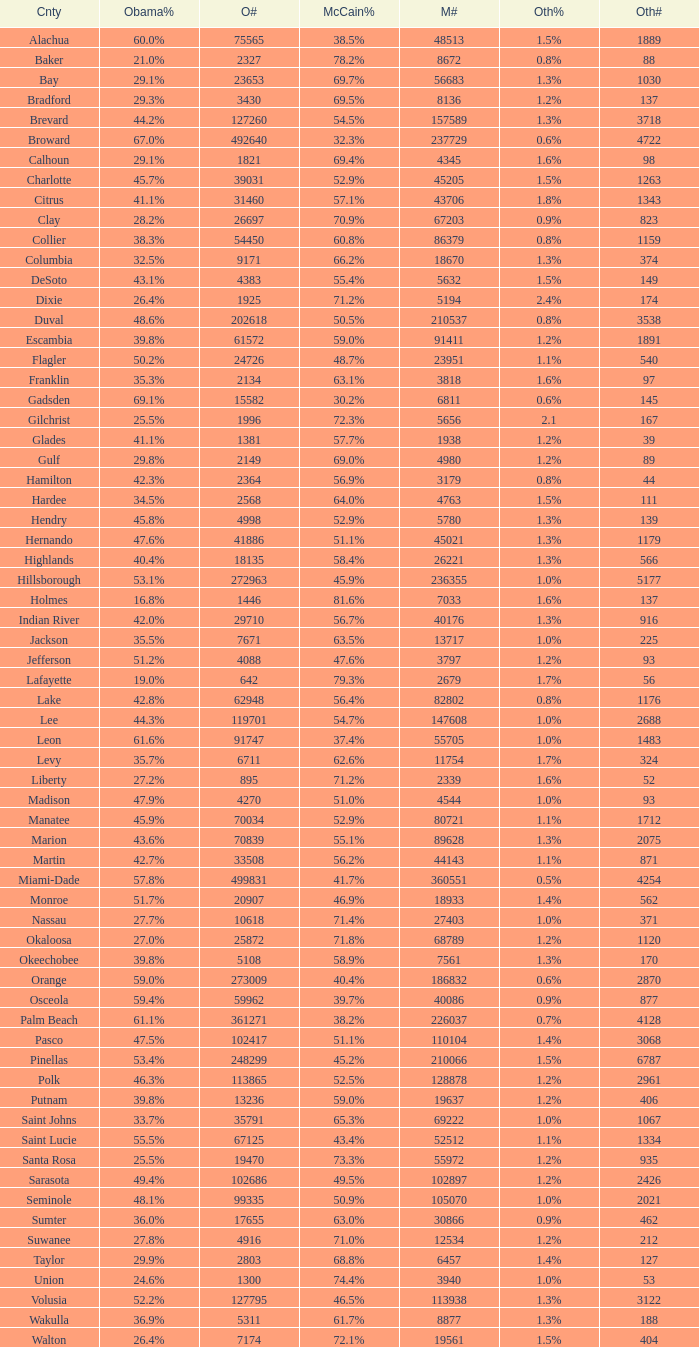Parse the full table. {'header': ['Cnty', 'Obama%', 'O#', 'McCain%', 'M#', 'Oth%', 'Oth#'], 'rows': [['Alachua', '60.0%', '75565', '38.5%', '48513', '1.5%', '1889'], ['Baker', '21.0%', '2327', '78.2%', '8672', '0.8%', '88'], ['Bay', '29.1%', '23653', '69.7%', '56683', '1.3%', '1030'], ['Bradford', '29.3%', '3430', '69.5%', '8136', '1.2%', '137'], ['Brevard', '44.2%', '127260', '54.5%', '157589', '1.3%', '3718'], ['Broward', '67.0%', '492640', '32.3%', '237729', '0.6%', '4722'], ['Calhoun', '29.1%', '1821', '69.4%', '4345', '1.6%', '98'], ['Charlotte', '45.7%', '39031', '52.9%', '45205', '1.5%', '1263'], ['Citrus', '41.1%', '31460', '57.1%', '43706', '1.8%', '1343'], ['Clay', '28.2%', '26697', '70.9%', '67203', '0.9%', '823'], ['Collier', '38.3%', '54450', '60.8%', '86379', '0.8%', '1159'], ['Columbia', '32.5%', '9171', '66.2%', '18670', '1.3%', '374'], ['DeSoto', '43.1%', '4383', '55.4%', '5632', '1.5%', '149'], ['Dixie', '26.4%', '1925', '71.2%', '5194', '2.4%', '174'], ['Duval', '48.6%', '202618', '50.5%', '210537', '0.8%', '3538'], ['Escambia', '39.8%', '61572', '59.0%', '91411', '1.2%', '1891'], ['Flagler', '50.2%', '24726', '48.7%', '23951', '1.1%', '540'], ['Franklin', '35.3%', '2134', '63.1%', '3818', '1.6%', '97'], ['Gadsden', '69.1%', '15582', '30.2%', '6811', '0.6%', '145'], ['Gilchrist', '25.5%', '1996', '72.3%', '5656', '2.1', '167'], ['Glades', '41.1%', '1381', '57.7%', '1938', '1.2%', '39'], ['Gulf', '29.8%', '2149', '69.0%', '4980', '1.2%', '89'], ['Hamilton', '42.3%', '2364', '56.9%', '3179', '0.8%', '44'], ['Hardee', '34.5%', '2568', '64.0%', '4763', '1.5%', '111'], ['Hendry', '45.8%', '4998', '52.9%', '5780', '1.3%', '139'], ['Hernando', '47.6%', '41886', '51.1%', '45021', '1.3%', '1179'], ['Highlands', '40.4%', '18135', '58.4%', '26221', '1.3%', '566'], ['Hillsborough', '53.1%', '272963', '45.9%', '236355', '1.0%', '5177'], ['Holmes', '16.8%', '1446', '81.6%', '7033', '1.6%', '137'], ['Indian River', '42.0%', '29710', '56.7%', '40176', '1.3%', '916'], ['Jackson', '35.5%', '7671', '63.5%', '13717', '1.0%', '225'], ['Jefferson', '51.2%', '4088', '47.6%', '3797', '1.2%', '93'], ['Lafayette', '19.0%', '642', '79.3%', '2679', '1.7%', '56'], ['Lake', '42.8%', '62948', '56.4%', '82802', '0.8%', '1176'], ['Lee', '44.3%', '119701', '54.7%', '147608', '1.0%', '2688'], ['Leon', '61.6%', '91747', '37.4%', '55705', '1.0%', '1483'], ['Levy', '35.7%', '6711', '62.6%', '11754', '1.7%', '324'], ['Liberty', '27.2%', '895', '71.2%', '2339', '1.6%', '52'], ['Madison', '47.9%', '4270', '51.0%', '4544', '1.0%', '93'], ['Manatee', '45.9%', '70034', '52.9%', '80721', '1.1%', '1712'], ['Marion', '43.6%', '70839', '55.1%', '89628', '1.3%', '2075'], ['Martin', '42.7%', '33508', '56.2%', '44143', '1.1%', '871'], ['Miami-Dade', '57.8%', '499831', '41.7%', '360551', '0.5%', '4254'], ['Monroe', '51.7%', '20907', '46.9%', '18933', '1.4%', '562'], ['Nassau', '27.7%', '10618', '71.4%', '27403', '1.0%', '371'], ['Okaloosa', '27.0%', '25872', '71.8%', '68789', '1.2%', '1120'], ['Okeechobee', '39.8%', '5108', '58.9%', '7561', '1.3%', '170'], ['Orange', '59.0%', '273009', '40.4%', '186832', '0.6%', '2870'], ['Osceola', '59.4%', '59962', '39.7%', '40086', '0.9%', '877'], ['Palm Beach', '61.1%', '361271', '38.2%', '226037', '0.7%', '4128'], ['Pasco', '47.5%', '102417', '51.1%', '110104', '1.4%', '3068'], ['Pinellas', '53.4%', '248299', '45.2%', '210066', '1.5%', '6787'], ['Polk', '46.3%', '113865', '52.5%', '128878', '1.2%', '2961'], ['Putnam', '39.8%', '13236', '59.0%', '19637', '1.2%', '406'], ['Saint Johns', '33.7%', '35791', '65.3%', '69222', '1.0%', '1067'], ['Saint Lucie', '55.5%', '67125', '43.4%', '52512', '1.1%', '1334'], ['Santa Rosa', '25.5%', '19470', '73.3%', '55972', '1.2%', '935'], ['Sarasota', '49.4%', '102686', '49.5%', '102897', '1.2%', '2426'], ['Seminole', '48.1%', '99335', '50.9%', '105070', '1.0%', '2021'], ['Sumter', '36.0%', '17655', '63.0%', '30866', '0.9%', '462'], ['Suwanee', '27.8%', '4916', '71.0%', '12534', '1.2%', '212'], ['Taylor', '29.9%', '2803', '68.8%', '6457', '1.4%', '127'], ['Union', '24.6%', '1300', '74.4%', '3940', '1.0%', '53'], ['Volusia', '52.2%', '127795', '46.5%', '113938', '1.3%', '3122'], ['Wakulla', '36.9%', '5311', '61.7%', '8877', '1.3%', '188'], ['Walton', '26.4%', '7174', '72.1%', '19561', '1.5%', '404']]} How many numbers were recorded under McCain when Obama had 27.2% voters? 1.0. 